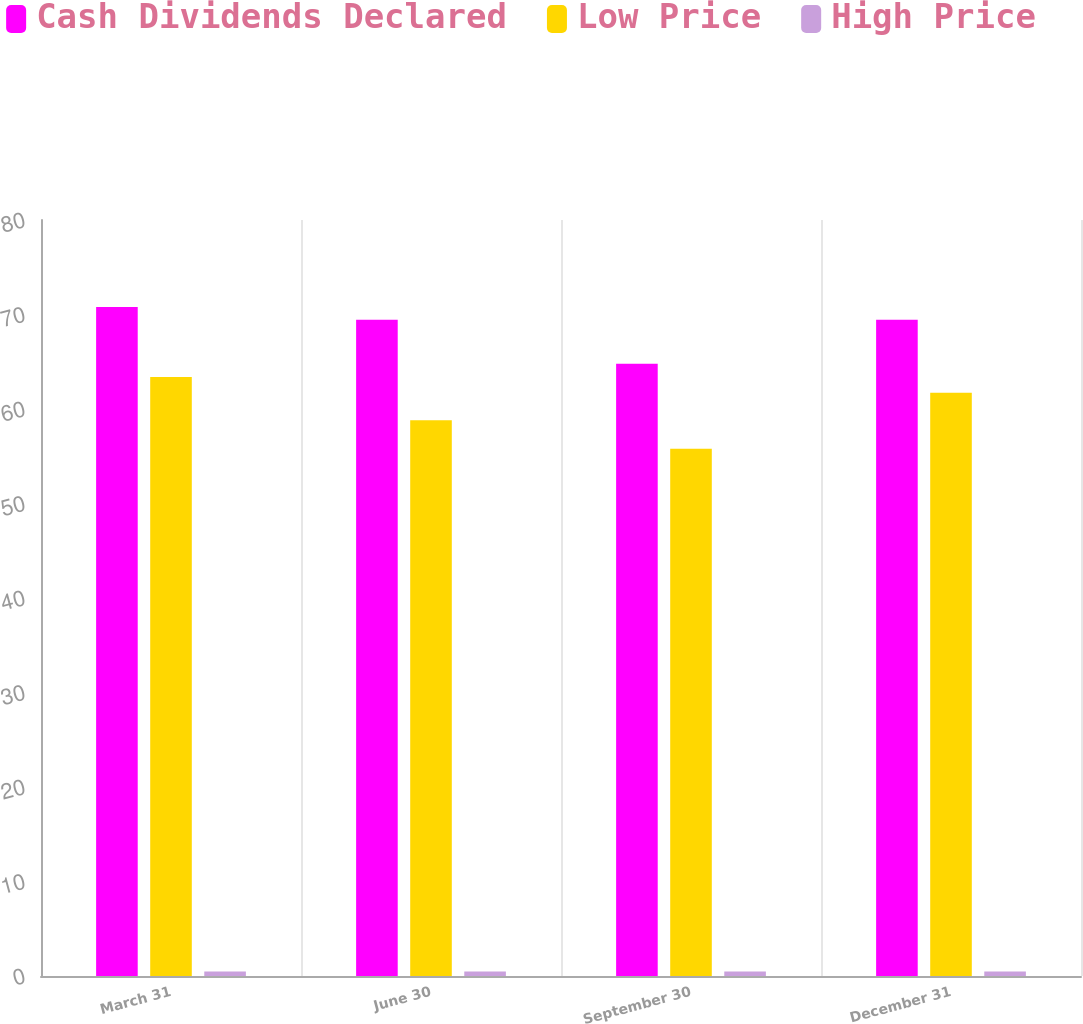<chart> <loc_0><loc_0><loc_500><loc_500><stacked_bar_chart><ecel><fcel>March 31<fcel>June 30<fcel>September 30<fcel>December 31<nl><fcel>Cash Dividends Declared<fcel>70.8<fcel>69.45<fcel>64.79<fcel>69.45<nl><fcel>Low Price<fcel>63.38<fcel>58.81<fcel>55.79<fcel>61.71<nl><fcel>High Price<fcel>0.48<fcel>0.48<fcel>0.48<fcel>0.48<nl></chart> 